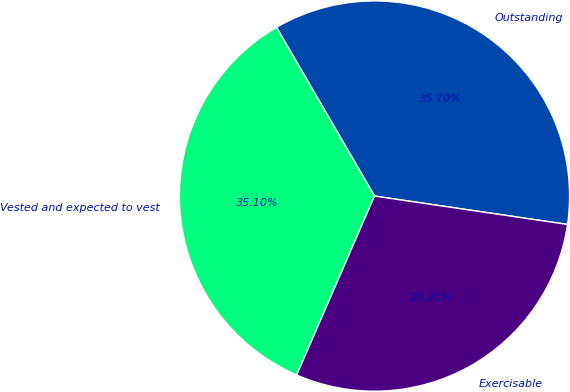Convert chart to OTSL. <chart><loc_0><loc_0><loc_500><loc_500><pie_chart><fcel>Outstanding<fcel>Vested and expected to vest<fcel>Exercisable<nl><fcel>35.7%<fcel>35.1%<fcel>29.2%<nl></chart> 